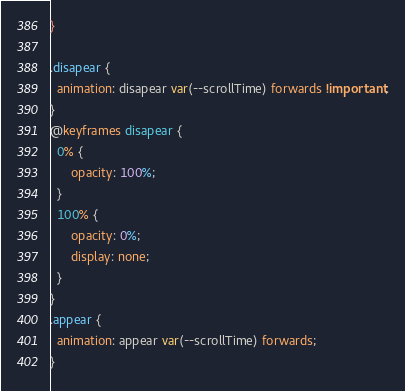<code> <loc_0><loc_0><loc_500><loc_500><_CSS_>}

.disapear {
  animation: disapear var(--scrollTime) forwards !important;
}
@keyframes disapear {
  0% {
      opacity: 100%;
  }
  100% {
      opacity: 0%;
      display: none;
  }
}
.appear {
  animation: appear var(--scrollTime) forwards;
}</code> 